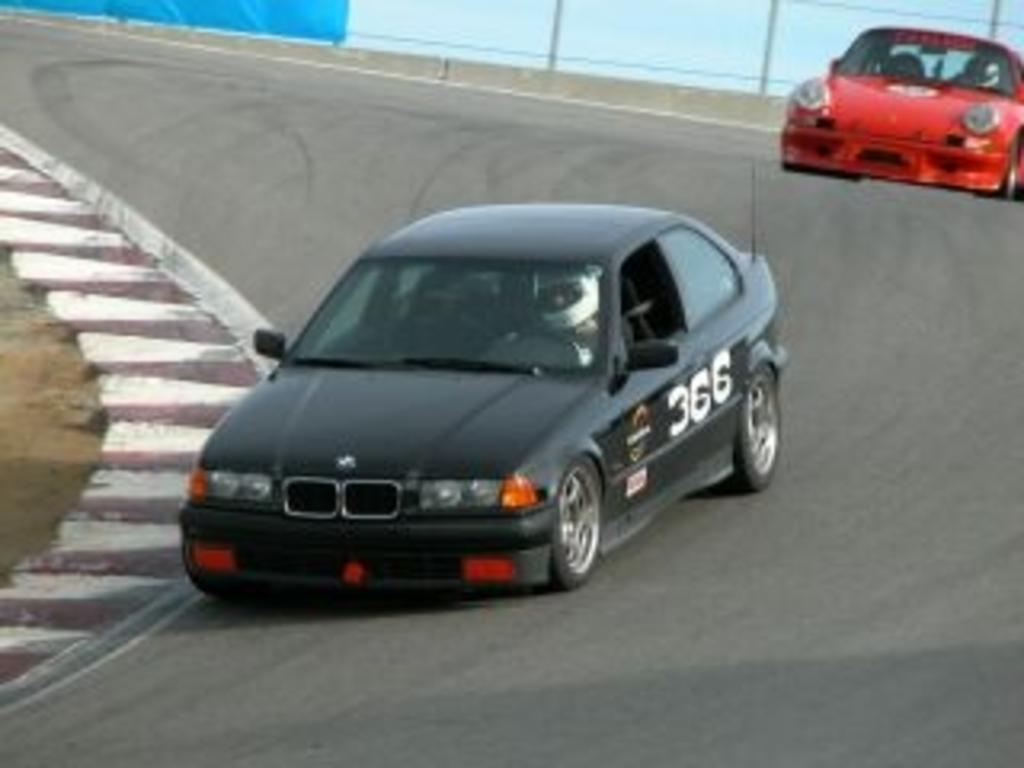How many cars can be seen in the image? There are two cars in the image. Where are the cars located? The cars are on the road. What else can be seen in the image besides the cars? There is a fence visible in the image. What type of mask is the car wearing in the image? There are no masks present in the image, as cars do not wear masks. 